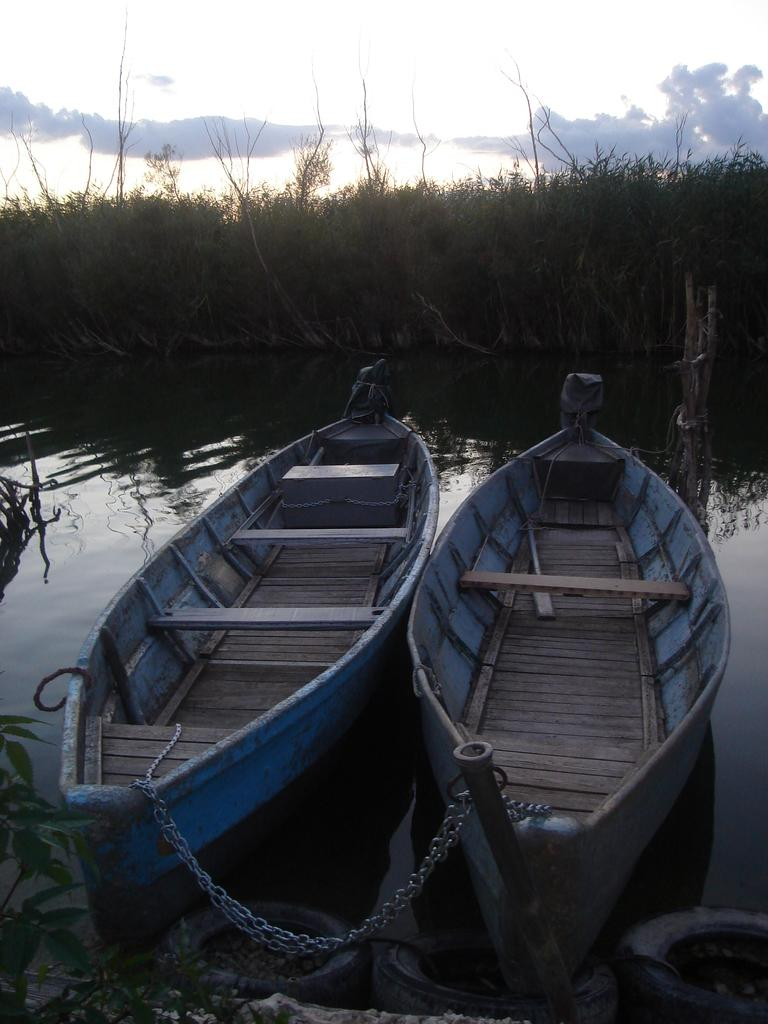How many boats can be seen in the image? There are two boats in the image. Where are the boats located? The boats are on water. What can be seen in the background of the image? There are trees and the sky visible in the background of the image. What type of apparel is the jellyfish wearing in the image? There is no jellyfish present in the image, and therefore no apparel can be observed. 